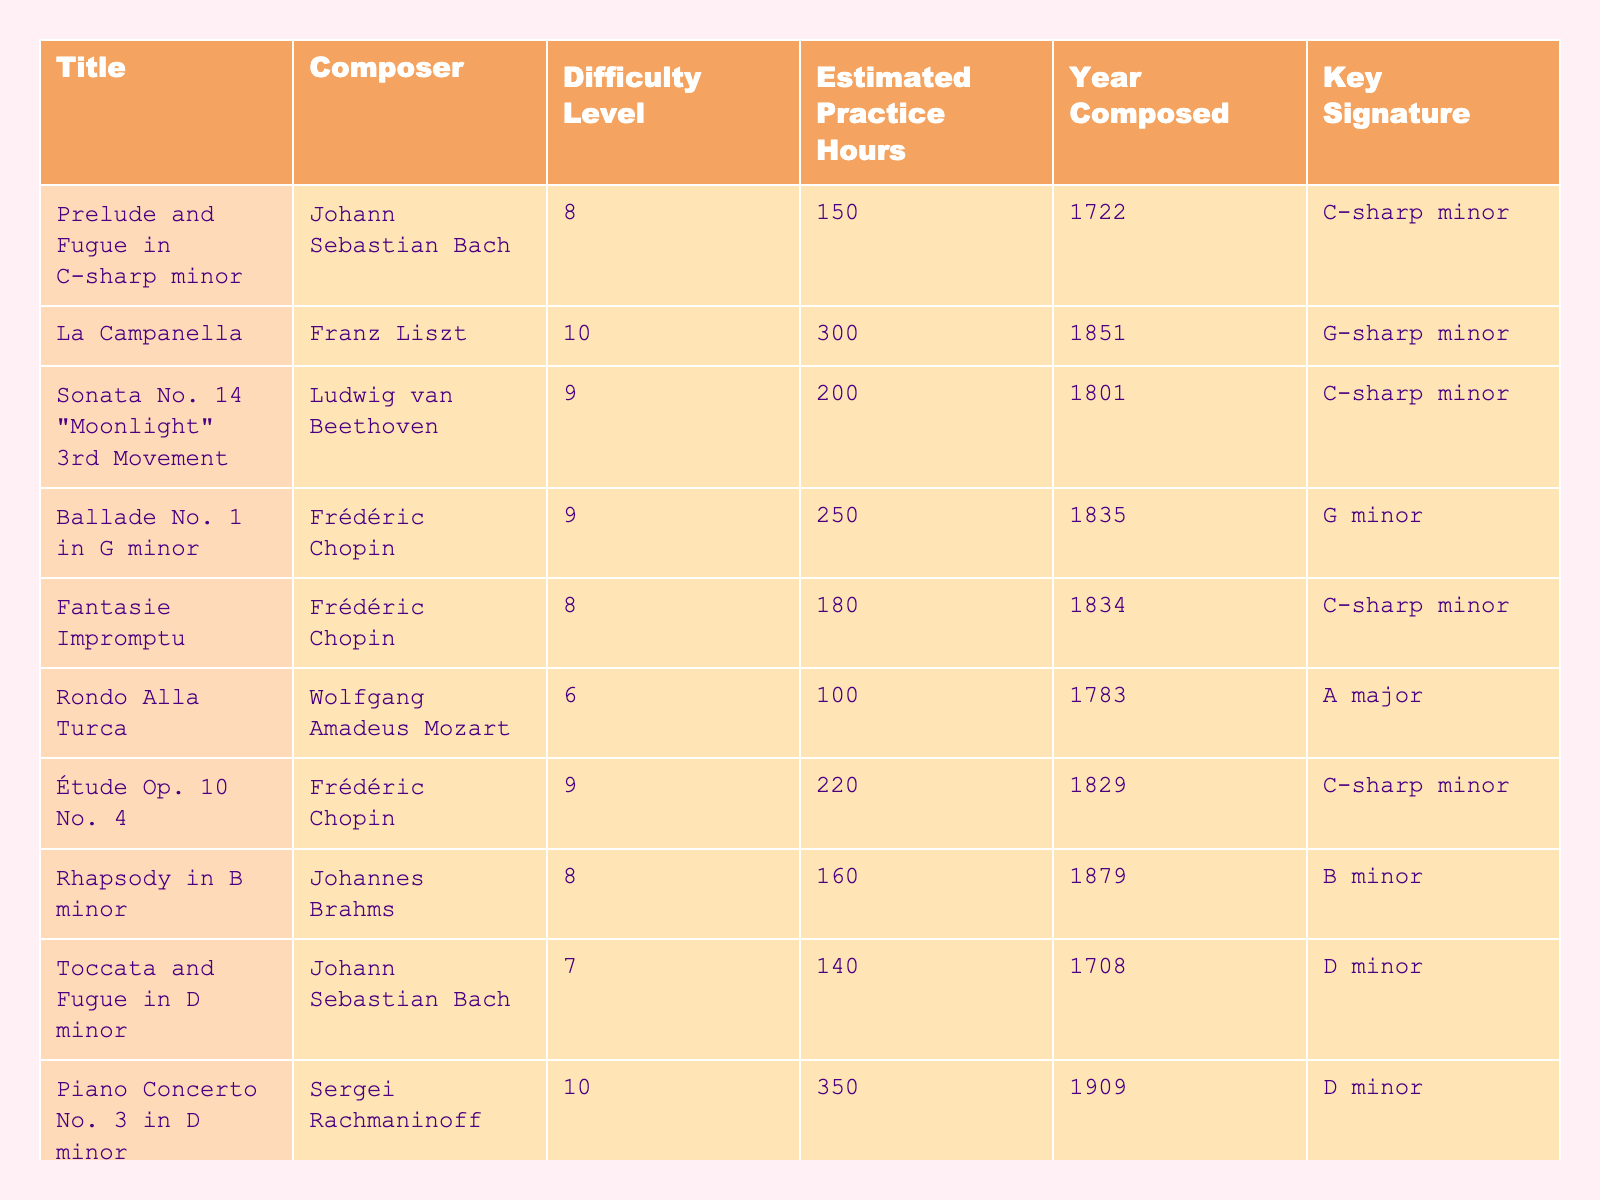What is the title of the piece with the highest difficulty level? To find the title, I will look for the highest value in the "Difficulty Level" column, which is 10. The piece with this level is "La Campanella" by Franz Liszt.
Answer: La Campanella How many estimated practice hours are needed for "Sonata No. 14 'Moonlight' 3rd Movement"? I will refer to the "Estimated Practice Hours" column for the title "Sonata No. 14 'Moonlight' 3rd Movement" and find that it requires 200 hours.
Answer: 200 Which composer has the most pieces listed in this table? I will count the occurrences of each composer in the "Composer" column. Frédéric Chopin appears three times, more than any other composer.
Answer: Frédéric Chopin What is the average difficulty level of all pieces listed? The sum of all difficulty levels (8 + 10 + 9 + 9 + 8 + 6 + 9 + 8 + 7 + 10) is 81. There are 10 pieces, so the average is 81/10 = 8.1.
Answer: 8.1 Is “Fantasie Impromptu” easier than “Prelude and Fugue in C-sharp minor”? I will compare the difficulty levels of both pieces. "Fantasie Impromptu" has a difficulty level of 8, while "Prelude and Fugue in C-sharp minor" has a level of 8. Since they are equal, the answer is no.
Answer: No What is the total estimated practice hours for all pieces combined? I will sum the estimated practice hours: 150 + 300 + 200 + 250 + 180 + 100 + 220 + 160 + 140 + 350 = 1950.
Answer: 1950 Which piece was composed the earliest and what year was it composed? I will scan the "Year Composed" column to find the earliest year. The earliest piece is the "Toccata and Fugue in D minor" composed in 1708.
Answer: Toccata and Fugue in D minor, 1708 How many pieces are composed in a minor key? I will check the "Key Signature" column and count the pieces in minor keys: C-sharp minor, G minor, C-sharp minor, B minor, D minor (5 pieces).
Answer: 5 Which piece requires the most estimated practice hours and how many? I will look at the "Estimated Practice Hours" column and find that "Piano Concerto No. 3 in D minor" requires the most hours at 350.
Answer: Piano Concerto No. 3 in D minor, 350 Are there any pieces in a major key? I will check the "Key Signature" column for any entries labeled as major. "Rondo Alla Turca" is in A major, so the answer is yes.
Answer: Yes What is the median of the estimated practice hours for these pieces? I will first list the practice hours in order: 100, 140, 150, 160, 180, 200, 220, 250, 300, 350 (10 pieces). The median would be the average of the 5th and 6th values, (180 + 200) / 2 = 190.
Answer: 190 